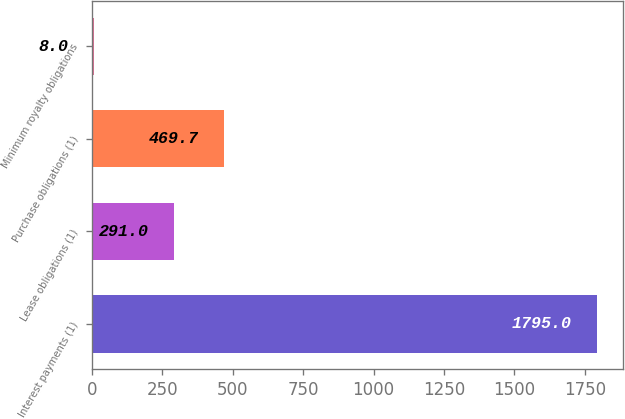Convert chart to OTSL. <chart><loc_0><loc_0><loc_500><loc_500><bar_chart><fcel>Interest payments (1)<fcel>Lease obligations (1)<fcel>Purchase obligations (1)<fcel>Minimum royalty obligations<nl><fcel>1795<fcel>291<fcel>469.7<fcel>8<nl></chart> 